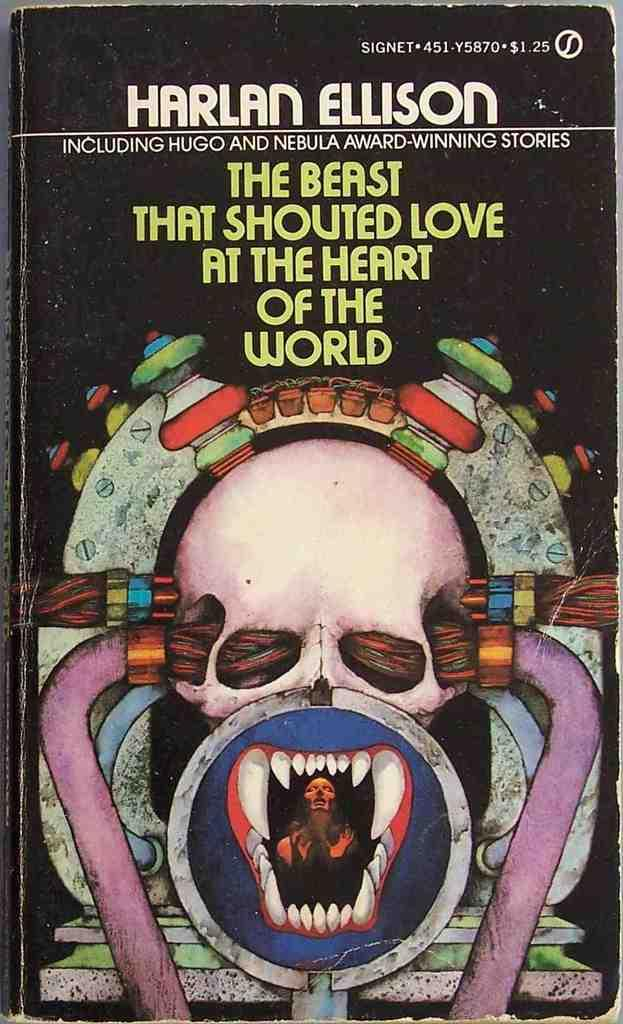What is present on the poster in the image? There is a poster in the image. What type of symbol is featured on the poster? The poster contains a danger sign symbol. What else can be found on the poster besides the symbol? There is text on the poster. Can you see a ghost requesting a system upgrade in the image? No, there is no ghost or system upgrade mentioned or depicted in the image. 